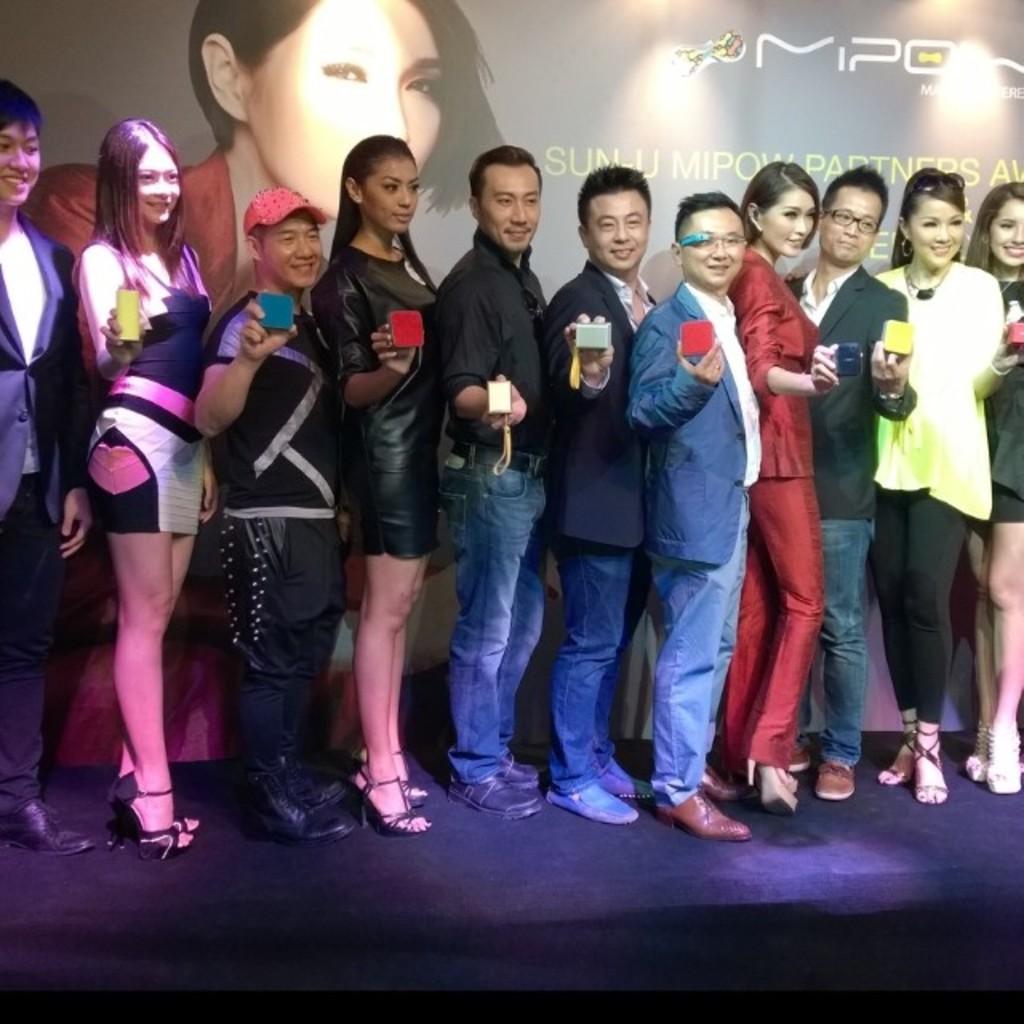Can you describe this image briefly? In this image we can see a few people standing and holding objects, in the background, we can see a poster with some image and text. 